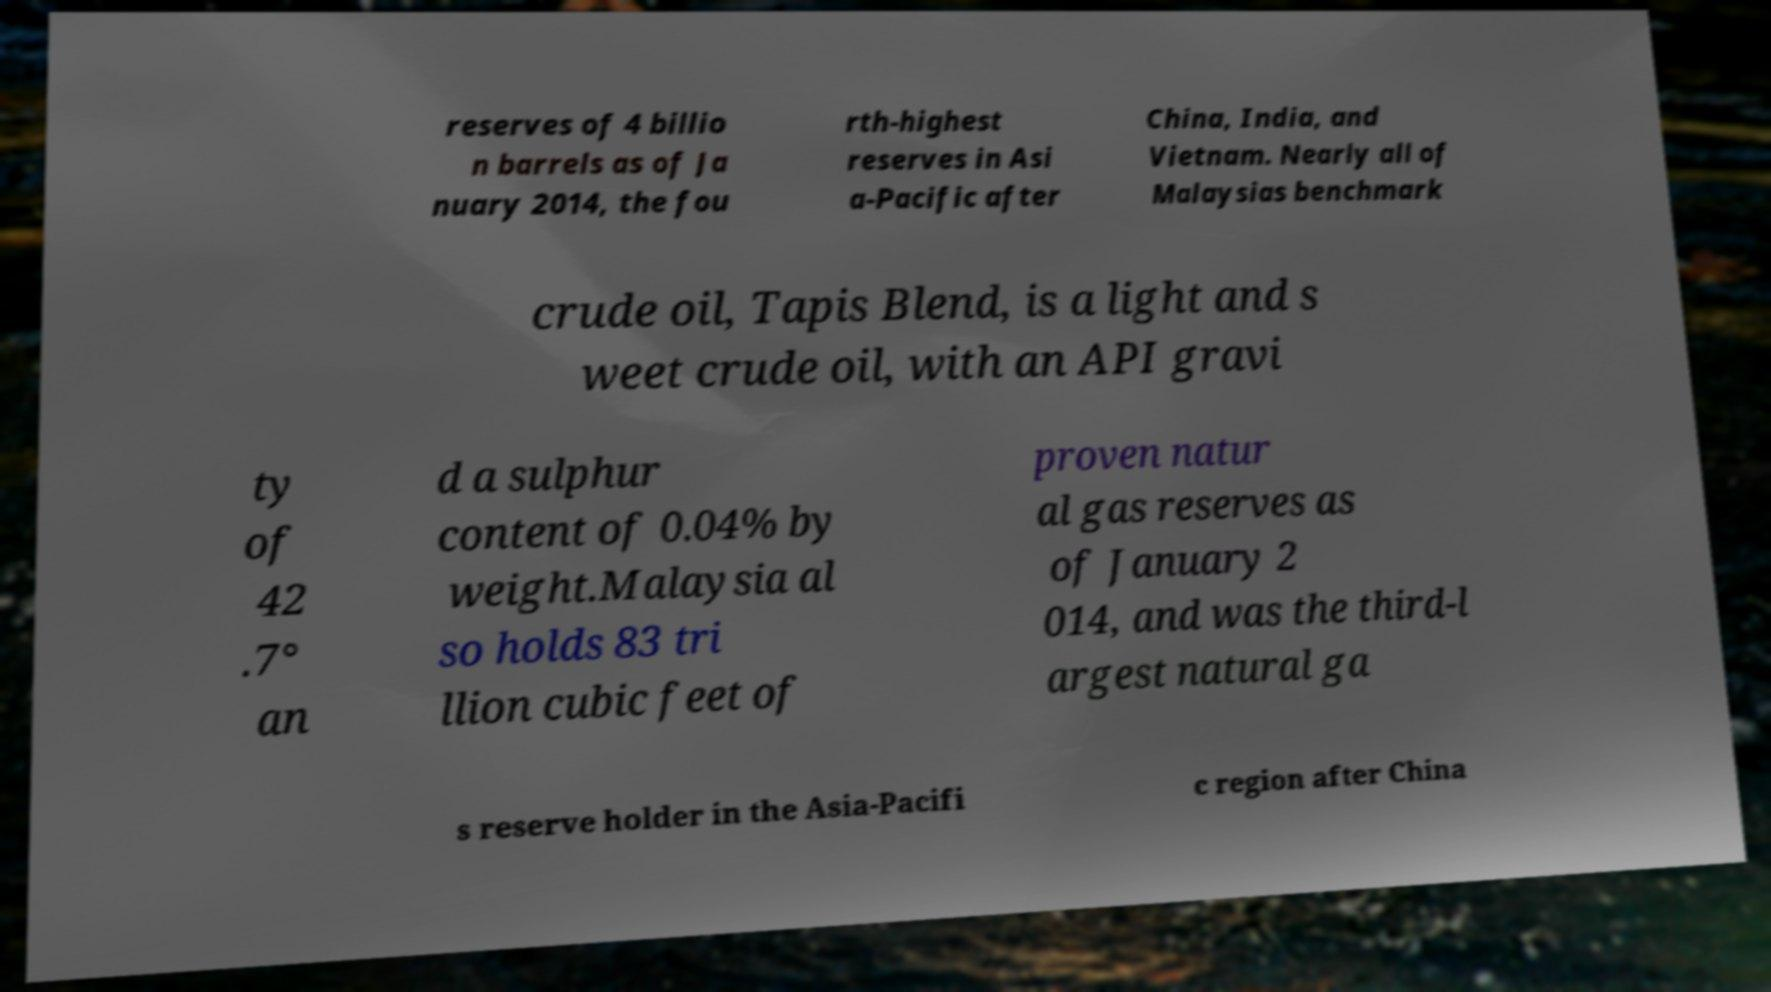Can you accurately transcribe the text from the provided image for me? reserves of 4 billio n barrels as of Ja nuary 2014, the fou rth-highest reserves in Asi a-Pacific after China, India, and Vietnam. Nearly all of Malaysias benchmark crude oil, Tapis Blend, is a light and s weet crude oil, with an API gravi ty of 42 .7° an d a sulphur content of 0.04% by weight.Malaysia al so holds 83 tri llion cubic feet of proven natur al gas reserves as of January 2 014, and was the third-l argest natural ga s reserve holder in the Asia-Pacifi c region after China 